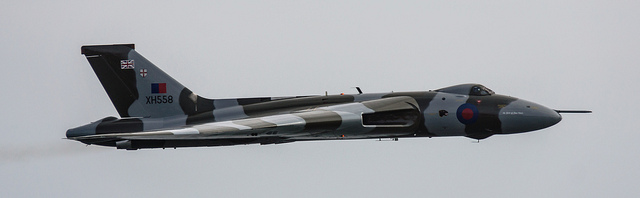Identify the text contained in this image. XH558 